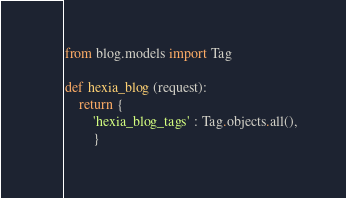Convert code to text. <code><loc_0><loc_0><loc_500><loc_500><_Python_>from blog.models import Tag

def hexia_blog (request):
    return {
        'hexia_blog_tags' : Tag.objects.all(),
        }</code> 